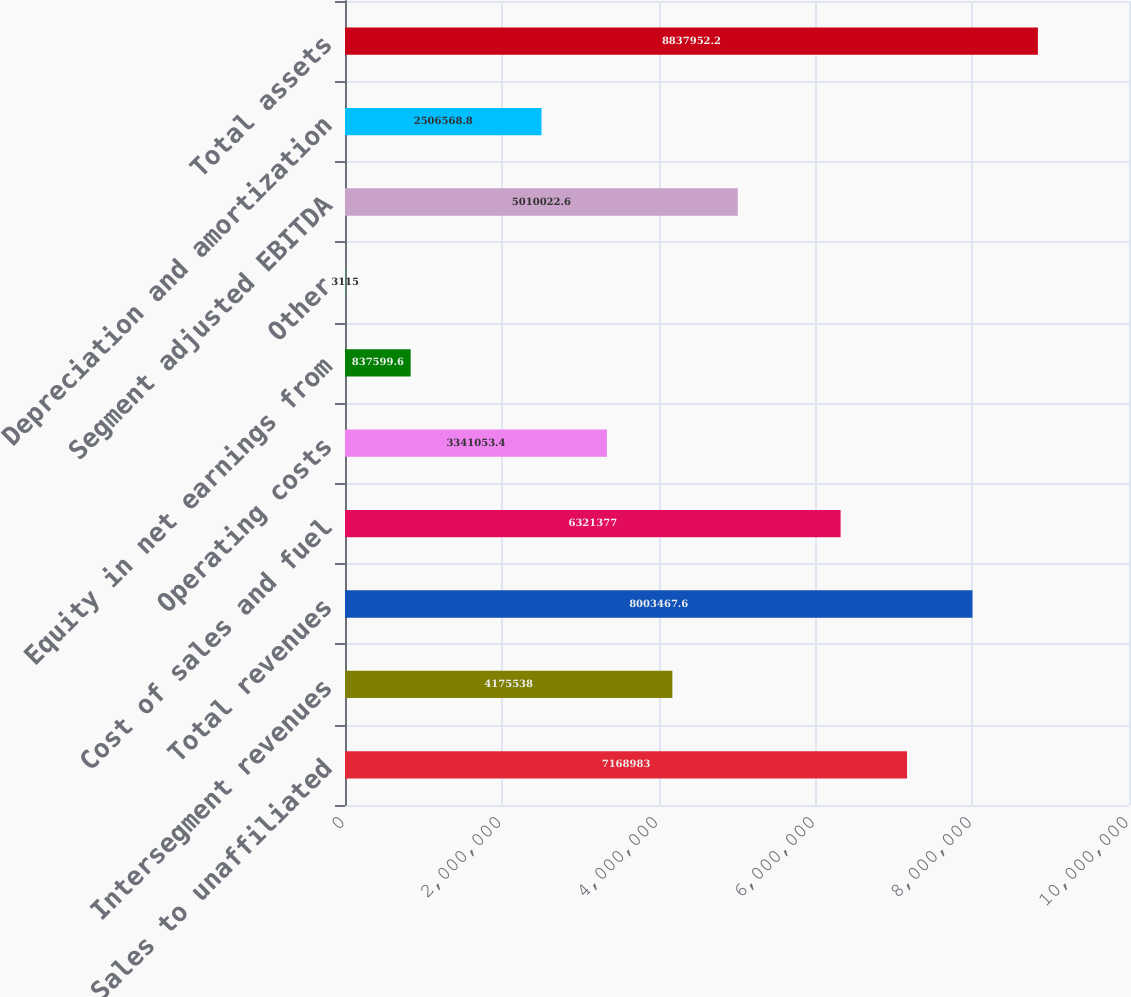Convert chart. <chart><loc_0><loc_0><loc_500><loc_500><bar_chart><fcel>Sales to unaffiliated<fcel>Intersegment revenues<fcel>Total revenues<fcel>Cost of sales and fuel<fcel>Operating costs<fcel>Equity in net earnings from<fcel>Other<fcel>Segment adjusted EBITDA<fcel>Depreciation and amortization<fcel>Total assets<nl><fcel>7.16898e+06<fcel>4.17554e+06<fcel>8.00347e+06<fcel>6.32138e+06<fcel>3.34105e+06<fcel>837600<fcel>3115<fcel>5.01002e+06<fcel>2.50657e+06<fcel>8.83795e+06<nl></chart> 